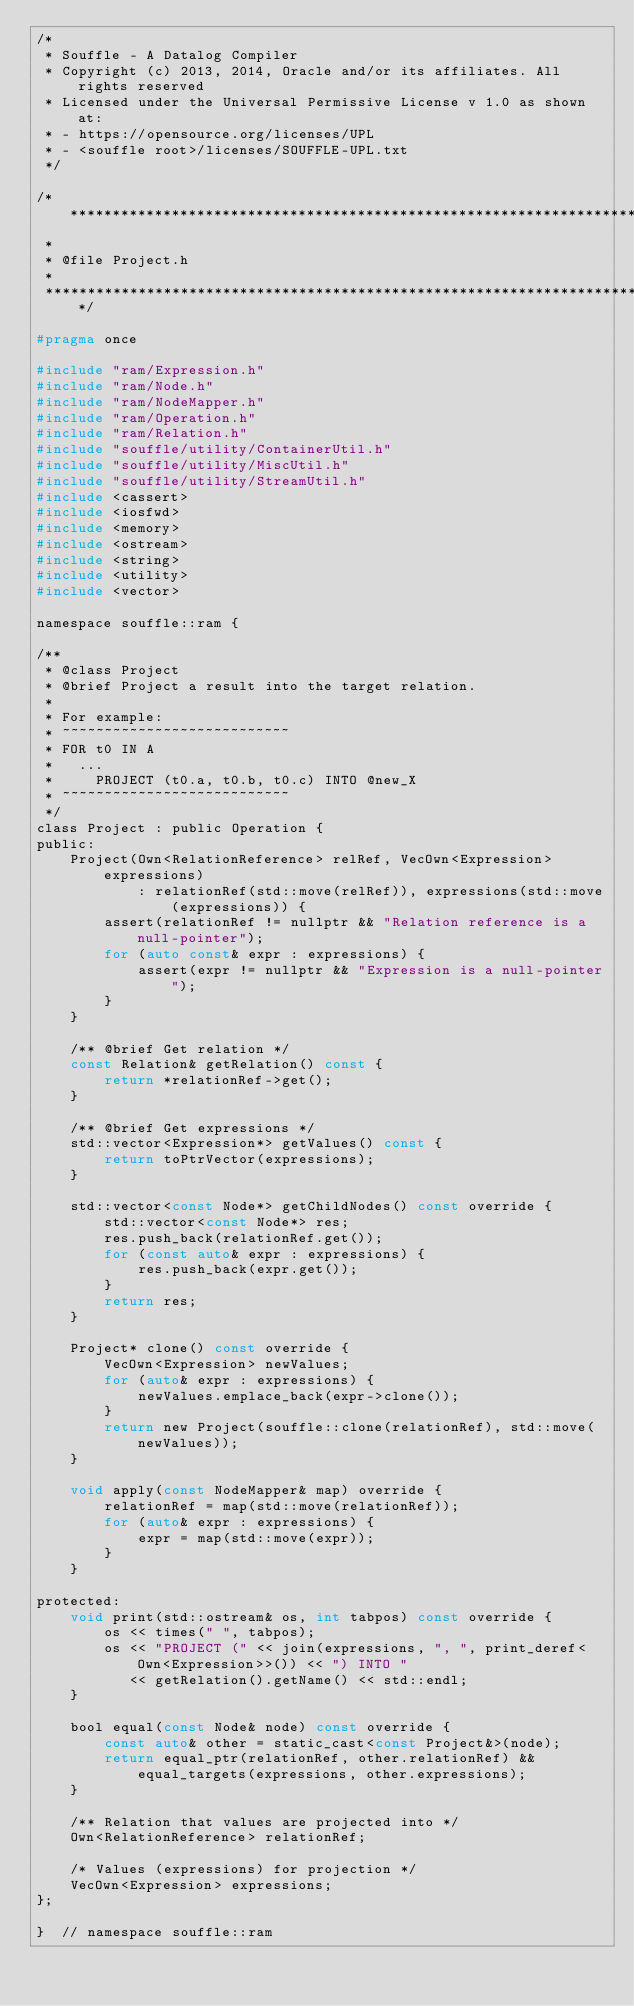<code> <loc_0><loc_0><loc_500><loc_500><_C_>/*
 * Souffle - A Datalog Compiler
 * Copyright (c) 2013, 2014, Oracle and/or its affiliates. All rights reserved
 * Licensed under the Universal Permissive License v 1.0 as shown at:
 * - https://opensource.org/licenses/UPL
 * - <souffle root>/licenses/SOUFFLE-UPL.txt
 */

/************************************************************************
 *
 * @file Project.h
 *
 ***********************************************************************/

#pragma once

#include "ram/Expression.h"
#include "ram/Node.h"
#include "ram/NodeMapper.h"
#include "ram/Operation.h"
#include "ram/Relation.h"
#include "souffle/utility/ContainerUtil.h"
#include "souffle/utility/MiscUtil.h"
#include "souffle/utility/StreamUtil.h"
#include <cassert>
#include <iosfwd>
#include <memory>
#include <ostream>
#include <string>
#include <utility>
#include <vector>

namespace souffle::ram {

/**
 * @class Project
 * @brief Project a result into the target relation.
 *
 * For example:
 * ~~~~~~~~~~~~~~~~~~~~~~~~~~~
 * FOR t0 IN A
 *   ...
 *     PROJECT (t0.a, t0.b, t0.c) INTO @new_X
 * ~~~~~~~~~~~~~~~~~~~~~~~~~~~
 */
class Project : public Operation {
public:
    Project(Own<RelationReference> relRef, VecOwn<Expression> expressions)
            : relationRef(std::move(relRef)), expressions(std::move(expressions)) {
        assert(relationRef != nullptr && "Relation reference is a null-pointer");
        for (auto const& expr : expressions) {
            assert(expr != nullptr && "Expression is a null-pointer");
        }
    }

    /** @brief Get relation */
    const Relation& getRelation() const {
        return *relationRef->get();
    }

    /** @brief Get expressions */
    std::vector<Expression*> getValues() const {
        return toPtrVector(expressions);
    }

    std::vector<const Node*> getChildNodes() const override {
        std::vector<const Node*> res;
        res.push_back(relationRef.get());
        for (const auto& expr : expressions) {
            res.push_back(expr.get());
        }
        return res;
    }

    Project* clone() const override {
        VecOwn<Expression> newValues;
        for (auto& expr : expressions) {
            newValues.emplace_back(expr->clone());
        }
        return new Project(souffle::clone(relationRef), std::move(newValues));
    }

    void apply(const NodeMapper& map) override {
        relationRef = map(std::move(relationRef));
        for (auto& expr : expressions) {
            expr = map(std::move(expr));
        }
    }

protected:
    void print(std::ostream& os, int tabpos) const override {
        os << times(" ", tabpos);
        os << "PROJECT (" << join(expressions, ", ", print_deref<Own<Expression>>()) << ") INTO "
           << getRelation().getName() << std::endl;
    }

    bool equal(const Node& node) const override {
        const auto& other = static_cast<const Project&>(node);
        return equal_ptr(relationRef, other.relationRef) && equal_targets(expressions, other.expressions);
    }

    /** Relation that values are projected into */
    Own<RelationReference> relationRef;

    /* Values (expressions) for projection */
    VecOwn<Expression> expressions;
};

}  // namespace souffle::ram
</code> 